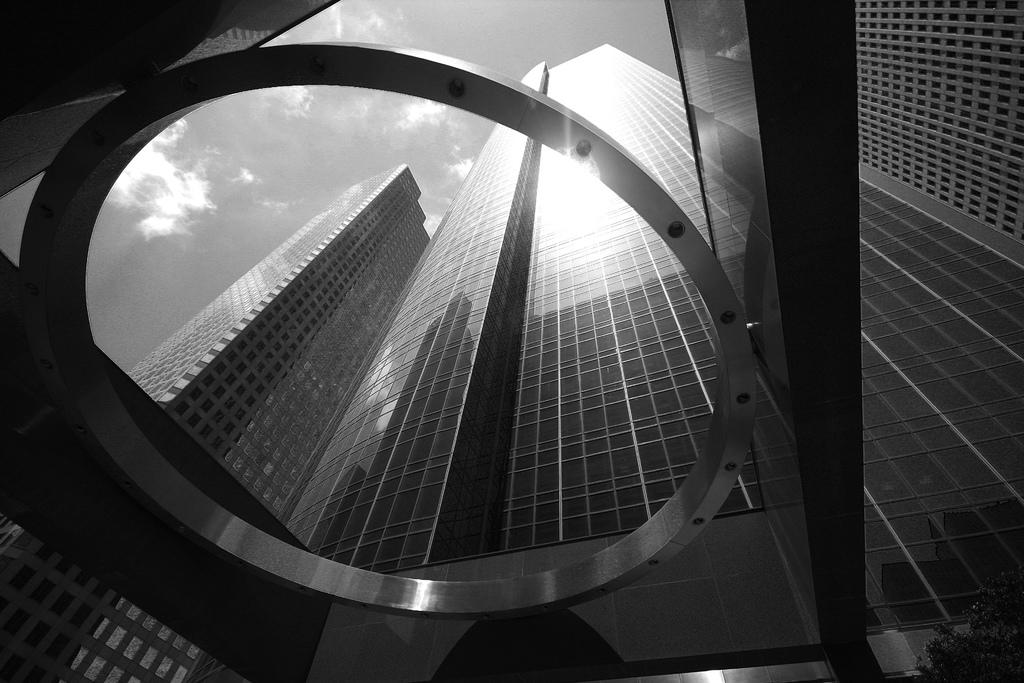What type of structures can be seen in the image? There are buildings in the image. What can be seen in the sky at the top of the image? Clouds are visible in the sky at the top of the image. What type of vegetation is on the right side of the image? There is a plant on the right side of the image. Can you see a ghost making a statement in the image? There is no ghost or statement present in the image. How many times does the plant pull itself up in the image? The plant does not move or pull itself up in the image; it is stationary. 